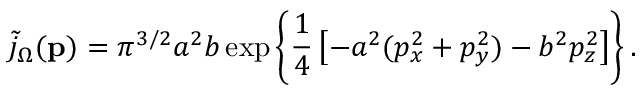<formula> <loc_0><loc_0><loc_500><loc_500>\tilde { j } _ { \Omega } ( { p } ) = \pi ^ { 3 / 2 } a ^ { 2 } b \exp \left \{ \frac { 1 } { 4 } \left [ - a ^ { 2 } ( p _ { x } ^ { 2 } + p _ { y } ^ { 2 } ) - b ^ { 2 } p _ { z } ^ { 2 } \right ] \right \} .</formula> 